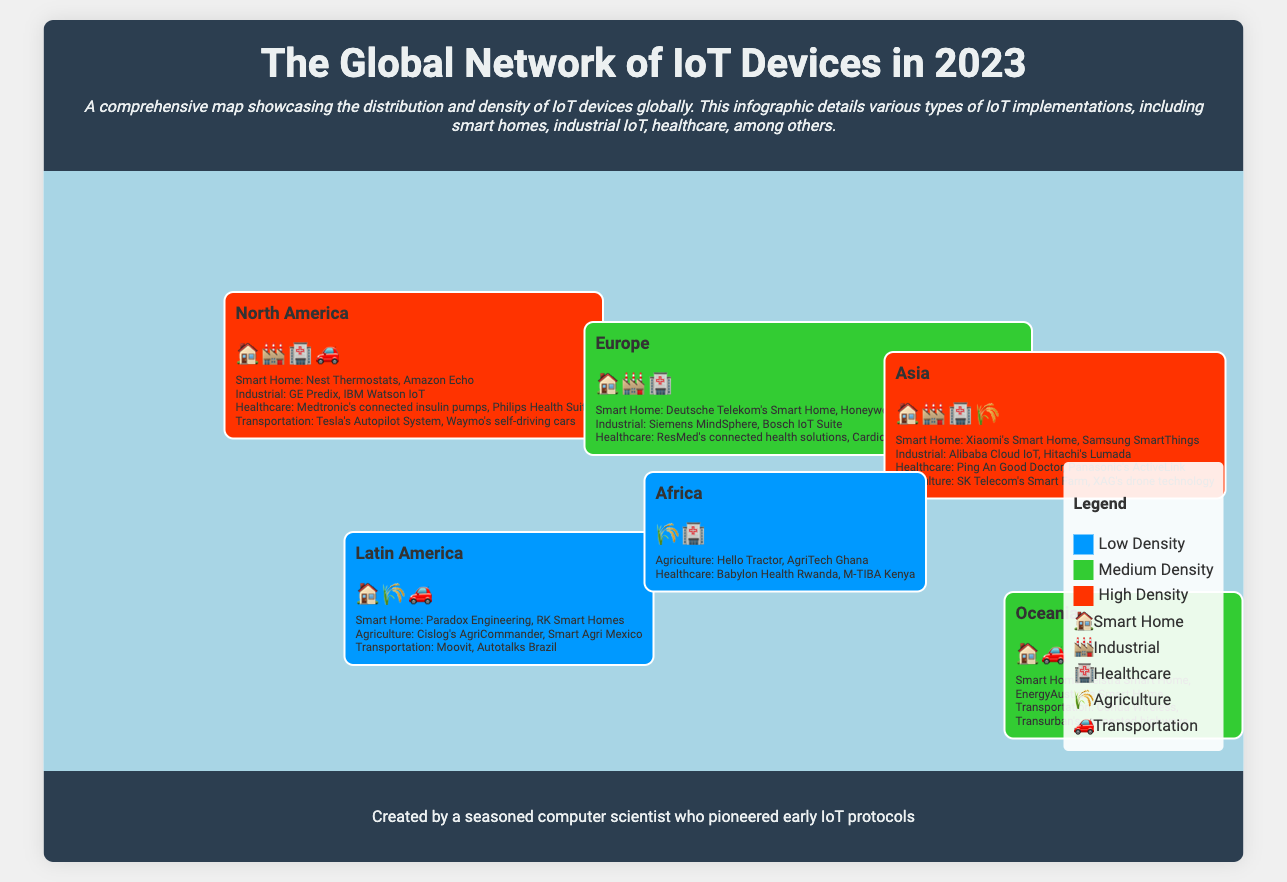What region has the highest density of IoT devices? The regions are color-coded, showing North America in red, indicating high density.
Answer: North America What types of IoT devices are represented in Asia? The region includes icons for smart homes, industrial IoT, healthcare, and agriculture.
Answer: Smart Home, Industrial, Healthcare, Agriculture Which region is associated with healthcare IoT solutions like Medtronic's connected insulin pumps? The document specifies healthcare examples in North America.
Answer: North America How many types of IoT implementations are identified in Europe? The section lists three types: smart home, industrial, and healthcare.
Answer: Three What is the background color that indicates low density of IoT devices? The legend describes the color for low density as blue.
Answer: Blue Which agriculture-related IoT solution is mentioned for Africa? The examples include Hello Tractor as an agricultural IoT solution.
Answer: Hello Tractor Which region features transportation IoT examples like Tesla's Autopilot System? The document states transportation examples are primarily in North America.
Answer: North America What is the dominant color representing medium density on the map? The legend specifies medium density is represented by green.
Answer: Green 